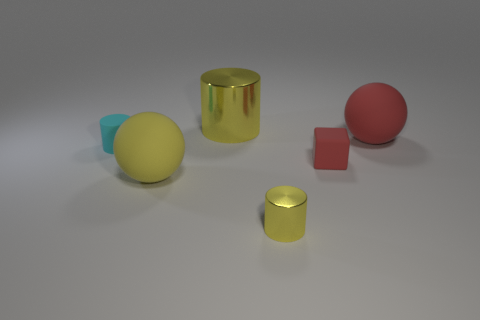Subtract all yellow cylinders. How many cylinders are left? 1 Add 3 large red objects. How many objects exist? 9 Subtract all cubes. How many objects are left? 5 Subtract all small objects. Subtract all yellow objects. How many objects are left? 0 Add 5 cyan things. How many cyan things are left? 6 Add 1 green metal things. How many green metal things exist? 1 Subtract 0 gray cubes. How many objects are left? 6 